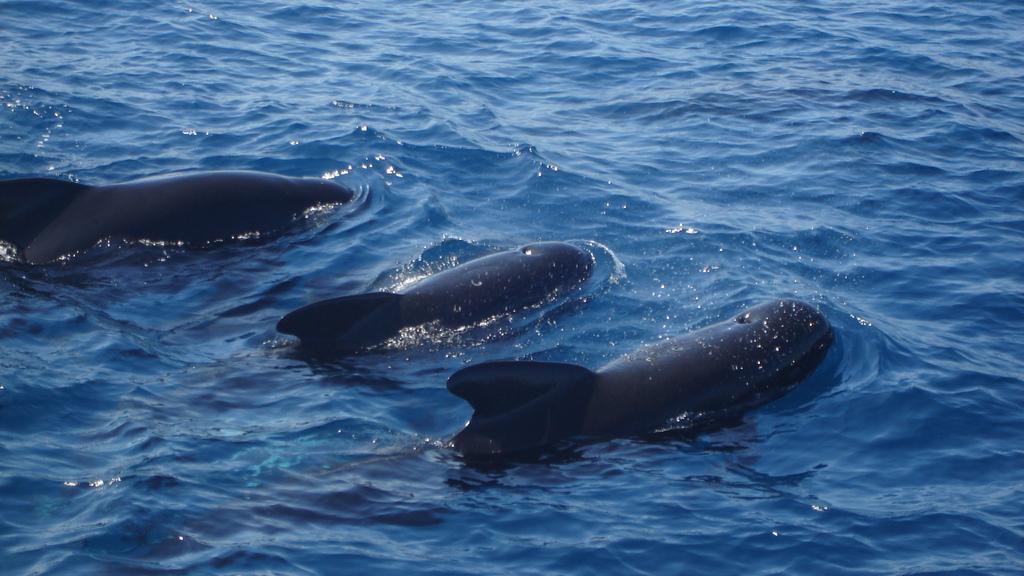Please provide a concise description of this image. In this image we can see some animals in the water. 